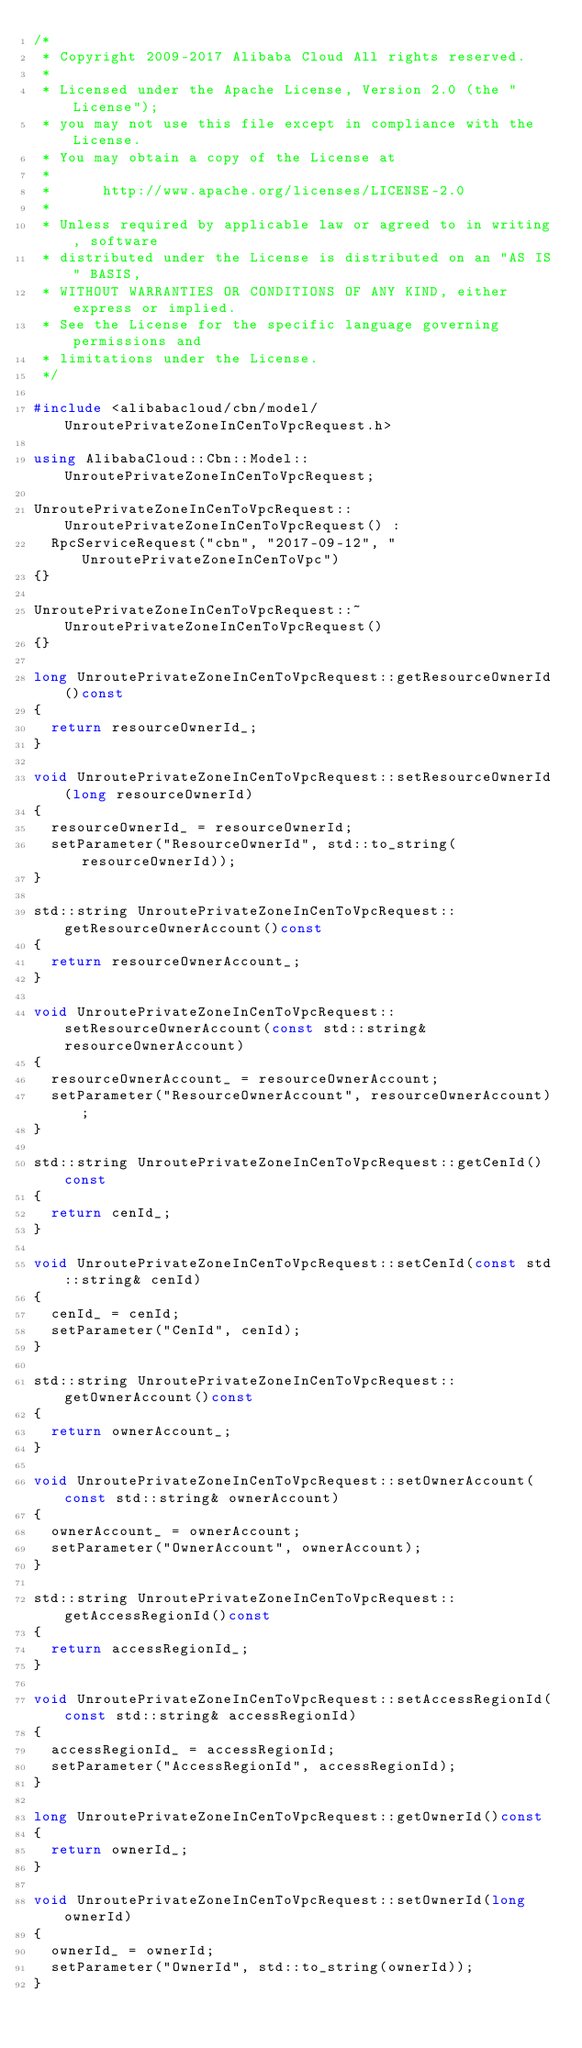Convert code to text. <code><loc_0><loc_0><loc_500><loc_500><_C++_>/*
 * Copyright 2009-2017 Alibaba Cloud All rights reserved.
 * 
 * Licensed under the Apache License, Version 2.0 (the "License");
 * you may not use this file except in compliance with the License.
 * You may obtain a copy of the License at
 * 
 *      http://www.apache.org/licenses/LICENSE-2.0
 * 
 * Unless required by applicable law or agreed to in writing, software
 * distributed under the License is distributed on an "AS IS" BASIS,
 * WITHOUT WARRANTIES OR CONDITIONS OF ANY KIND, either express or implied.
 * See the License for the specific language governing permissions and
 * limitations under the License.
 */

#include <alibabacloud/cbn/model/UnroutePrivateZoneInCenToVpcRequest.h>

using AlibabaCloud::Cbn::Model::UnroutePrivateZoneInCenToVpcRequest;

UnroutePrivateZoneInCenToVpcRequest::UnroutePrivateZoneInCenToVpcRequest() :
	RpcServiceRequest("cbn", "2017-09-12", "UnroutePrivateZoneInCenToVpc")
{}

UnroutePrivateZoneInCenToVpcRequest::~UnroutePrivateZoneInCenToVpcRequest()
{}

long UnroutePrivateZoneInCenToVpcRequest::getResourceOwnerId()const
{
	return resourceOwnerId_;
}

void UnroutePrivateZoneInCenToVpcRequest::setResourceOwnerId(long resourceOwnerId)
{
	resourceOwnerId_ = resourceOwnerId;
	setParameter("ResourceOwnerId", std::to_string(resourceOwnerId));
}

std::string UnroutePrivateZoneInCenToVpcRequest::getResourceOwnerAccount()const
{
	return resourceOwnerAccount_;
}

void UnroutePrivateZoneInCenToVpcRequest::setResourceOwnerAccount(const std::string& resourceOwnerAccount)
{
	resourceOwnerAccount_ = resourceOwnerAccount;
	setParameter("ResourceOwnerAccount", resourceOwnerAccount);
}

std::string UnroutePrivateZoneInCenToVpcRequest::getCenId()const
{
	return cenId_;
}

void UnroutePrivateZoneInCenToVpcRequest::setCenId(const std::string& cenId)
{
	cenId_ = cenId;
	setParameter("CenId", cenId);
}

std::string UnroutePrivateZoneInCenToVpcRequest::getOwnerAccount()const
{
	return ownerAccount_;
}

void UnroutePrivateZoneInCenToVpcRequest::setOwnerAccount(const std::string& ownerAccount)
{
	ownerAccount_ = ownerAccount;
	setParameter("OwnerAccount", ownerAccount);
}

std::string UnroutePrivateZoneInCenToVpcRequest::getAccessRegionId()const
{
	return accessRegionId_;
}

void UnroutePrivateZoneInCenToVpcRequest::setAccessRegionId(const std::string& accessRegionId)
{
	accessRegionId_ = accessRegionId;
	setParameter("AccessRegionId", accessRegionId);
}

long UnroutePrivateZoneInCenToVpcRequest::getOwnerId()const
{
	return ownerId_;
}

void UnroutePrivateZoneInCenToVpcRequest::setOwnerId(long ownerId)
{
	ownerId_ = ownerId;
	setParameter("OwnerId", std::to_string(ownerId));
}

</code> 